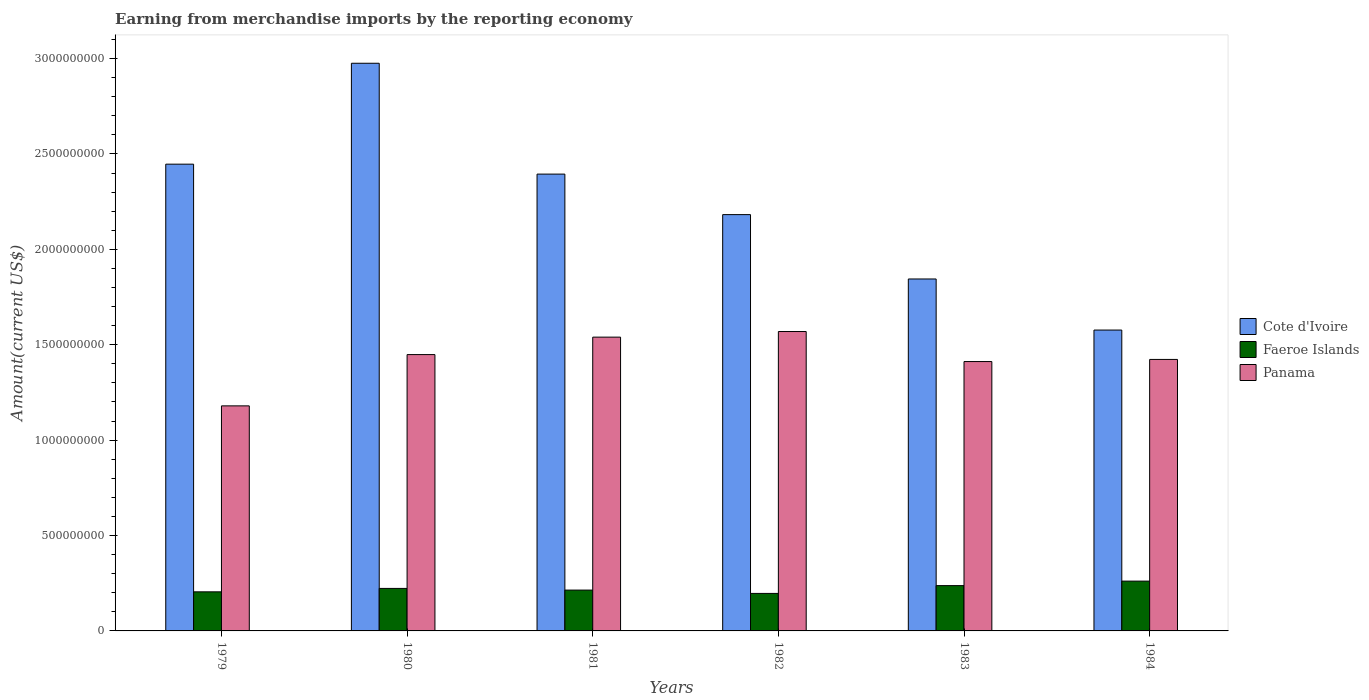Are the number of bars per tick equal to the number of legend labels?
Provide a succinct answer. Yes. Are the number of bars on each tick of the X-axis equal?
Ensure brevity in your answer.  Yes. How many bars are there on the 6th tick from the right?
Ensure brevity in your answer.  3. What is the label of the 2nd group of bars from the left?
Keep it short and to the point. 1980. What is the amount earned from merchandise imports in Panama in 1983?
Offer a terse response. 1.41e+09. Across all years, what is the maximum amount earned from merchandise imports in Cote d'Ivoire?
Make the answer very short. 2.98e+09. Across all years, what is the minimum amount earned from merchandise imports in Cote d'Ivoire?
Provide a short and direct response. 1.58e+09. In which year was the amount earned from merchandise imports in Faeroe Islands maximum?
Your answer should be very brief. 1984. In which year was the amount earned from merchandise imports in Faeroe Islands minimum?
Ensure brevity in your answer.  1982. What is the total amount earned from merchandise imports in Cote d'Ivoire in the graph?
Your response must be concise. 1.34e+1. What is the difference between the amount earned from merchandise imports in Cote d'Ivoire in 1982 and that in 1984?
Your answer should be very brief. 6.05e+08. What is the difference between the amount earned from merchandise imports in Panama in 1983 and the amount earned from merchandise imports in Cote d'Ivoire in 1984?
Provide a short and direct response. -1.65e+08. What is the average amount earned from merchandise imports in Faeroe Islands per year?
Your answer should be very brief. 2.23e+08. In the year 1982, what is the difference between the amount earned from merchandise imports in Cote d'Ivoire and amount earned from merchandise imports in Panama?
Provide a short and direct response. 6.13e+08. What is the ratio of the amount earned from merchandise imports in Cote d'Ivoire in 1979 to that in 1980?
Offer a very short reply. 0.82. What is the difference between the highest and the second highest amount earned from merchandise imports in Faeroe Islands?
Your response must be concise. 2.36e+07. What is the difference between the highest and the lowest amount earned from merchandise imports in Cote d'Ivoire?
Your answer should be very brief. 1.40e+09. In how many years, is the amount earned from merchandise imports in Cote d'Ivoire greater than the average amount earned from merchandise imports in Cote d'Ivoire taken over all years?
Your response must be concise. 3. What does the 2nd bar from the left in 1983 represents?
Offer a terse response. Faeroe Islands. What does the 3rd bar from the right in 1982 represents?
Provide a succinct answer. Cote d'Ivoire. How many bars are there?
Provide a short and direct response. 18. How many years are there in the graph?
Your answer should be compact. 6. What is the difference between two consecutive major ticks on the Y-axis?
Your response must be concise. 5.00e+08. Are the values on the major ticks of Y-axis written in scientific E-notation?
Your response must be concise. No. Does the graph contain any zero values?
Provide a succinct answer. No. Does the graph contain grids?
Your response must be concise. No. Where does the legend appear in the graph?
Make the answer very short. Center right. How are the legend labels stacked?
Keep it short and to the point. Vertical. What is the title of the graph?
Keep it short and to the point. Earning from merchandise imports by the reporting economy. What is the label or title of the Y-axis?
Keep it short and to the point. Amount(current US$). What is the Amount(current US$) in Cote d'Ivoire in 1979?
Ensure brevity in your answer.  2.45e+09. What is the Amount(current US$) of Faeroe Islands in 1979?
Make the answer very short. 2.05e+08. What is the Amount(current US$) of Panama in 1979?
Offer a terse response. 1.18e+09. What is the Amount(current US$) of Cote d'Ivoire in 1980?
Give a very brief answer. 2.98e+09. What is the Amount(current US$) of Faeroe Islands in 1980?
Your answer should be compact. 2.23e+08. What is the Amount(current US$) of Panama in 1980?
Your response must be concise. 1.45e+09. What is the Amount(current US$) in Cote d'Ivoire in 1981?
Your answer should be very brief. 2.39e+09. What is the Amount(current US$) in Faeroe Islands in 1981?
Provide a short and direct response. 2.14e+08. What is the Amount(current US$) of Panama in 1981?
Keep it short and to the point. 1.54e+09. What is the Amount(current US$) of Cote d'Ivoire in 1982?
Provide a short and direct response. 2.18e+09. What is the Amount(current US$) in Faeroe Islands in 1982?
Keep it short and to the point. 1.97e+08. What is the Amount(current US$) in Panama in 1982?
Make the answer very short. 1.57e+09. What is the Amount(current US$) of Cote d'Ivoire in 1983?
Offer a very short reply. 1.84e+09. What is the Amount(current US$) of Faeroe Islands in 1983?
Provide a succinct answer. 2.37e+08. What is the Amount(current US$) in Panama in 1983?
Provide a succinct answer. 1.41e+09. What is the Amount(current US$) of Cote d'Ivoire in 1984?
Ensure brevity in your answer.  1.58e+09. What is the Amount(current US$) of Faeroe Islands in 1984?
Give a very brief answer. 2.61e+08. What is the Amount(current US$) in Panama in 1984?
Make the answer very short. 1.42e+09. Across all years, what is the maximum Amount(current US$) of Cote d'Ivoire?
Give a very brief answer. 2.98e+09. Across all years, what is the maximum Amount(current US$) of Faeroe Islands?
Ensure brevity in your answer.  2.61e+08. Across all years, what is the maximum Amount(current US$) of Panama?
Ensure brevity in your answer.  1.57e+09. Across all years, what is the minimum Amount(current US$) in Cote d'Ivoire?
Your response must be concise. 1.58e+09. Across all years, what is the minimum Amount(current US$) of Faeroe Islands?
Provide a short and direct response. 1.97e+08. Across all years, what is the minimum Amount(current US$) of Panama?
Give a very brief answer. 1.18e+09. What is the total Amount(current US$) in Cote d'Ivoire in the graph?
Offer a terse response. 1.34e+1. What is the total Amount(current US$) of Faeroe Islands in the graph?
Ensure brevity in your answer.  1.34e+09. What is the total Amount(current US$) in Panama in the graph?
Offer a terse response. 8.57e+09. What is the difference between the Amount(current US$) of Cote d'Ivoire in 1979 and that in 1980?
Offer a very short reply. -5.29e+08. What is the difference between the Amount(current US$) in Faeroe Islands in 1979 and that in 1980?
Give a very brief answer. -1.79e+07. What is the difference between the Amount(current US$) in Panama in 1979 and that in 1980?
Give a very brief answer. -2.69e+08. What is the difference between the Amount(current US$) in Cote d'Ivoire in 1979 and that in 1981?
Provide a succinct answer. 5.20e+07. What is the difference between the Amount(current US$) of Faeroe Islands in 1979 and that in 1981?
Keep it short and to the point. -9.18e+06. What is the difference between the Amount(current US$) in Panama in 1979 and that in 1981?
Ensure brevity in your answer.  -3.60e+08. What is the difference between the Amount(current US$) in Cote d'Ivoire in 1979 and that in 1982?
Offer a terse response. 2.64e+08. What is the difference between the Amount(current US$) in Faeroe Islands in 1979 and that in 1982?
Provide a short and direct response. 8.24e+06. What is the difference between the Amount(current US$) of Panama in 1979 and that in 1982?
Ensure brevity in your answer.  -3.90e+08. What is the difference between the Amount(current US$) of Cote d'Ivoire in 1979 and that in 1983?
Provide a short and direct response. 6.02e+08. What is the difference between the Amount(current US$) in Faeroe Islands in 1979 and that in 1983?
Keep it short and to the point. -3.26e+07. What is the difference between the Amount(current US$) in Panama in 1979 and that in 1983?
Provide a short and direct response. -2.32e+08. What is the difference between the Amount(current US$) of Cote d'Ivoire in 1979 and that in 1984?
Make the answer very short. 8.69e+08. What is the difference between the Amount(current US$) of Faeroe Islands in 1979 and that in 1984?
Provide a succinct answer. -5.62e+07. What is the difference between the Amount(current US$) in Panama in 1979 and that in 1984?
Your answer should be very brief. -2.43e+08. What is the difference between the Amount(current US$) in Cote d'Ivoire in 1980 and that in 1981?
Offer a very short reply. 5.81e+08. What is the difference between the Amount(current US$) in Faeroe Islands in 1980 and that in 1981?
Your response must be concise. 8.76e+06. What is the difference between the Amount(current US$) of Panama in 1980 and that in 1981?
Provide a short and direct response. -9.15e+07. What is the difference between the Amount(current US$) in Cote d'Ivoire in 1980 and that in 1982?
Give a very brief answer. 7.93e+08. What is the difference between the Amount(current US$) of Faeroe Islands in 1980 and that in 1982?
Your answer should be very brief. 2.62e+07. What is the difference between the Amount(current US$) in Panama in 1980 and that in 1982?
Offer a terse response. -1.21e+08. What is the difference between the Amount(current US$) in Cote d'Ivoire in 1980 and that in 1983?
Your answer should be very brief. 1.13e+09. What is the difference between the Amount(current US$) of Faeroe Islands in 1980 and that in 1983?
Offer a very short reply. -1.47e+07. What is the difference between the Amount(current US$) in Panama in 1980 and that in 1983?
Keep it short and to the point. 3.65e+07. What is the difference between the Amount(current US$) of Cote d'Ivoire in 1980 and that in 1984?
Your answer should be very brief. 1.40e+09. What is the difference between the Amount(current US$) in Faeroe Islands in 1980 and that in 1984?
Provide a succinct answer. -3.83e+07. What is the difference between the Amount(current US$) of Panama in 1980 and that in 1984?
Provide a short and direct response. 2.54e+07. What is the difference between the Amount(current US$) of Cote d'Ivoire in 1981 and that in 1982?
Ensure brevity in your answer.  2.12e+08. What is the difference between the Amount(current US$) in Faeroe Islands in 1981 and that in 1982?
Your answer should be very brief. 1.74e+07. What is the difference between the Amount(current US$) of Panama in 1981 and that in 1982?
Offer a terse response. -2.93e+07. What is the difference between the Amount(current US$) in Cote d'Ivoire in 1981 and that in 1983?
Make the answer very short. 5.50e+08. What is the difference between the Amount(current US$) of Faeroe Islands in 1981 and that in 1983?
Offer a very short reply. -2.34e+07. What is the difference between the Amount(current US$) of Panama in 1981 and that in 1983?
Give a very brief answer. 1.28e+08. What is the difference between the Amount(current US$) in Cote d'Ivoire in 1981 and that in 1984?
Provide a short and direct response. 8.17e+08. What is the difference between the Amount(current US$) in Faeroe Islands in 1981 and that in 1984?
Give a very brief answer. -4.70e+07. What is the difference between the Amount(current US$) in Panama in 1981 and that in 1984?
Ensure brevity in your answer.  1.17e+08. What is the difference between the Amount(current US$) of Cote d'Ivoire in 1982 and that in 1983?
Offer a terse response. 3.37e+08. What is the difference between the Amount(current US$) in Faeroe Islands in 1982 and that in 1983?
Offer a terse response. -4.09e+07. What is the difference between the Amount(current US$) of Panama in 1982 and that in 1983?
Provide a succinct answer. 1.57e+08. What is the difference between the Amount(current US$) of Cote d'Ivoire in 1982 and that in 1984?
Offer a terse response. 6.05e+08. What is the difference between the Amount(current US$) in Faeroe Islands in 1982 and that in 1984?
Your answer should be very brief. -6.44e+07. What is the difference between the Amount(current US$) of Panama in 1982 and that in 1984?
Keep it short and to the point. 1.46e+08. What is the difference between the Amount(current US$) of Cote d'Ivoire in 1983 and that in 1984?
Provide a succinct answer. 2.68e+08. What is the difference between the Amount(current US$) in Faeroe Islands in 1983 and that in 1984?
Keep it short and to the point. -2.36e+07. What is the difference between the Amount(current US$) of Panama in 1983 and that in 1984?
Your answer should be compact. -1.11e+07. What is the difference between the Amount(current US$) of Cote d'Ivoire in 1979 and the Amount(current US$) of Faeroe Islands in 1980?
Offer a terse response. 2.22e+09. What is the difference between the Amount(current US$) of Cote d'Ivoire in 1979 and the Amount(current US$) of Panama in 1980?
Ensure brevity in your answer.  9.98e+08. What is the difference between the Amount(current US$) of Faeroe Islands in 1979 and the Amount(current US$) of Panama in 1980?
Offer a terse response. -1.24e+09. What is the difference between the Amount(current US$) of Cote d'Ivoire in 1979 and the Amount(current US$) of Faeroe Islands in 1981?
Your answer should be very brief. 2.23e+09. What is the difference between the Amount(current US$) of Cote d'Ivoire in 1979 and the Amount(current US$) of Panama in 1981?
Offer a terse response. 9.07e+08. What is the difference between the Amount(current US$) of Faeroe Islands in 1979 and the Amount(current US$) of Panama in 1981?
Offer a terse response. -1.34e+09. What is the difference between the Amount(current US$) of Cote d'Ivoire in 1979 and the Amount(current US$) of Faeroe Islands in 1982?
Keep it short and to the point. 2.25e+09. What is the difference between the Amount(current US$) in Cote d'Ivoire in 1979 and the Amount(current US$) in Panama in 1982?
Keep it short and to the point. 8.77e+08. What is the difference between the Amount(current US$) of Faeroe Islands in 1979 and the Amount(current US$) of Panama in 1982?
Provide a succinct answer. -1.36e+09. What is the difference between the Amount(current US$) of Cote d'Ivoire in 1979 and the Amount(current US$) of Faeroe Islands in 1983?
Provide a short and direct response. 2.21e+09. What is the difference between the Amount(current US$) of Cote d'Ivoire in 1979 and the Amount(current US$) of Panama in 1983?
Provide a succinct answer. 1.03e+09. What is the difference between the Amount(current US$) in Faeroe Islands in 1979 and the Amount(current US$) in Panama in 1983?
Provide a short and direct response. -1.21e+09. What is the difference between the Amount(current US$) in Cote d'Ivoire in 1979 and the Amount(current US$) in Faeroe Islands in 1984?
Give a very brief answer. 2.19e+09. What is the difference between the Amount(current US$) in Cote d'Ivoire in 1979 and the Amount(current US$) in Panama in 1984?
Provide a short and direct response. 1.02e+09. What is the difference between the Amount(current US$) of Faeroe Islands in 1979 and the Amount(current US$) of Panama in 1984?
Make the answer very short. -1.22e+09. What is the difference between the Amount(current US$) in Cote d'Ivoire in 1980 and the Amount(current US$) in Faeroe Islands in 1981?
Your response must be concise. 2.76e+09. What is the difference between the Amount(current US$) in Cote d'Ivoire in 1980 and the Amount(current US$) in Panama in 1981?
Your answer should be very brief. 1.44e+09. What is the difference between the Amount(current US$) in Faeroe Islands in 1980 and the Amount(current US$) in Panama in 1981?
Make the answer very short. -1.32e+09. What is the difference between the Amount(current US$) in Cote d'Ivoire in 1980 and the Amount(current US$) in Faeroe Islands in 1982?
Ensure brevity in your answer.  2.78e+09. What is the difference between the Amount(current US$) of Cote d'Ivoire in 1980 and the Amount(current US$) of Panama in 1982?
Provide a succinct answer. 1.41e+09. What is the difference between the Amount(current US$) of Faeroe Islands in 1980 and the Amount(current US$) of Panama in 1982?
Your response must be concise. -1.35e+09. What is the difference between the Amount(current US$) in Cote d'Ivoire in 1980 and the Amount(current US$) in Faeroe Islands in 1983?
Provide a short and direct response. 2.74e+09. What is the difference between the Amount(current US$) of Cote d'Ivoire in 1980 and the Amount(current US$) of Panama in 1983?
Your answer should be compact. 1.56e+09. What is the difference between the Amount(current US$) of Faeroe Islands in 1980 and the Amount(current US$) of Panama in 1983?
Your answer should be compact. -1.19e+09. What is the difference between the Amount(current US$) in Cote d'Ivoire in 1980 and the Amount(current US$) in Faeroe Islands in 1984?
Offer a very short reply. 2.71e+09. What is the difference between the Amount(current US$) in Cote d'Ivoire in 1980 and the Amount(current US$) in Panama in 1984?
Make the answer very short. 1.55e+09. What is the difference between the Amount(current US$) in Faeroe Islands in 1980 and the Amount(current US$) in Panama in 1984?
Your answer should be compact. -1.20e+09. What is the difference between the Amount(current US$) of Cote d'Ivoire in 1981 and the Amount(current US$) of Faeroe Islands in 1982?
Your answer should be very brief. 2.20e+09. What is the difference between the Amount(current US$) in Cote d'Ivoire in 1981 and the Amount(current US$) in Panama in 1982?
Give a very brief answer. 8.25e+08. What is the difference between the Amount(current US$) of Faeroe Islands in 1981 and the Amount(current US$) of Panama in 1982?
Offer a very short reply. -1.36e+09. What is the difference between the Amount(current US$) of Cote d'Ivoire in 1981 and the Amount(current US$) of Faeroe Islands in 1983?
Give a very brief answer. 2.16e+09. What is the difference between the Amount(current US$) in Cote d'Ivoire in 1981 and the Amount(current US$) in Panama in 1983?
Make the answer very short. 9.83e+08. What is the difference between the Amount(current US$) in Faeroe Islands in 1981 and the Amount(current US$) in Panama in 1983?
Offer a terse response. -1.20e+09. What is the difference between the Amount(current US$) of Cote d'Ivoire in 1981 and the Amount(current US$) of Faeroe Islands in 1984?
Keep it short and to the point. 2.13e+09. What is the difference between the Amount(current US$) of Cote d'Ivoire in 1981 and the Amount(current US$) of Panama in 1984?
Provide a succinct answer. 9.71e+08. What is the difference between the Amount(current US$) of Faeroe Islands in 1981 and the Amount(current US$) of Panama in 1984?
Give a very brief answer. -1.21e+09. What is the difference between the Amount(current US$) in Cote d'Ivoire in 1982 and the Amount(current US$) in Faeroe Islands in 1983?
Make the answer very short. 1.94e+09. What is the difference between the Amount(current US$) of Cote d'Ivoire in 1982 and the Amount(current US$) of Panama in 1983?
Ensure brevity in your answer.  7.70e+08. What is the difference between the Amount(current US$) of Faeroe Islands in 1982 and the Amount(current US$) of Panama in 1983?
Give a very brief answer. -1.22e+09. What is the difference between the Amount(current US$) in Cote d'Ivoire in 1982 and the Amount(current US$) in Faeroe Islands in 1984?
Your response must be concise. 1.92e+09. What is the difference between the Amount(current US$) of Cote d'Ivoire in 1982 and the Amount(current US$) of Panama in 1984?
Your response must be concise. 7.59e+08. What is the difference between the Amount(current US$) in Faeroe Islands in 1982 and the Amount(current US$) in Panama in 1984?
Ensure brevity in your answer.  -1.23e+09. What is the difference between the Amount(current US$) of Cote d'Ivoire in 1983 and the Amount(current US$) of Faeroe Islands in 1984?
Provide a succinct answer. 1.58e+09. What is the difference between the Amount(current US$) in Cote d'Ivoire in 1983 and the Amount(current US$) in Panama in 1984?
Give a very brief answer. 4.22e+08. What is the difference between the Amount(current US$) in Faeroe Islands in 1983 and the Amount(current US$) in Panama in 1984?
Offer a very short reply. -1.19e+09. What is the average Amount(current US$) in Cote d'Ivoire per year?
Provide a succinct answer. 2.24e+09. What is the average Amount(current US$) of Faeroe Islands per year?
Offer a terse response. 2.23e+08. What is the average Amount(current US$) of Panama per year?
Offer a very short reply. 1.43e+09. In the year 1979, what is the difference between the Amount(current US$) of Cote d'Ivoire and Amount(current US$) of Faeroe Islands?
Your answer should be very brief. 2.24e+09. In the year 1979, what is the difference between the Amount(current US$) of Cote d'Ivoire and Amount(current US$) of Panama?
Offer a terse response. 1.27e+09. In the year 1979, what is the difference between the Amount(current US$) of Faeroe Islands and Amount(current US$) of Panama?
Provide a short and direct response. -9.75e+08. In the year 1980, what is the difference between the Amount(current US$) of Cote d'Ivoire and Amount(current US$) of Faeroe Islands?
Offer a terse response. 2.75e+09. In the year 1980, what is the difference between the Amount(current US$) of Cote d'Ivoire and Amount(current US$) of Panama?
Give a very brief answer. 1.53e+09. In the year 1980, what is the difference between the Amount(current US$) in Faeroe Islands and Amount(current US$) in Panama?
Offer a very short reply. -1.23e+09. In the year 1981, what is the difference between the Amount(current US$) of Cote d'Ivoire and Amount(current US$) of Faeroe Islands?
Offer a very short reply. 2.18e+09. In the year 1981, what is the difference between the Amount(current US$) in Cote d'Ivoire and Amount(current US$) in Panama?
Your response must be concise. 8.55e+08. In the year 1981, what is the difference between the Amount(current US$) of Faeroe Islands and Amount(current US$) of Panama?
Make the answer very short. -1.33e+09. In the year 1982, what is the difference between the Amount(current US$) in Cote d'Ivoire and Amount(current US$) in Faeroe Islands?
Your answer should be very brief. 1.99e+09. In the year 1982, what is the difference between the Amount(current US$) in Cote d'Ivoire and Amount(current US$) in Panama?
Provide a short and direct response. 6.13e+08. In the year 1982, what is the difference between the Amount(current US$) of Faeroe Islands and Amount(current US$) of Panama?
Provide a short and direct response. -1.37e+09. In the year 1983, what is the difference between the Amount(current US$) of Cote d'Ivoire and Amount(current US$) of Faeroe Islands?
Keep it short and to the point. 1.61e+09. In the year 1983, what is the difference between the Amount(current US$) of Cote d'Ivoire and Amount(current US$) of Panama?
Offer a terse response. 4.33e+08. In the year 1983, what is the difference between the Amount(current US$) of Faeroe Islands and Amount(current US$) of Panama?
Your answer should be very brief. -1.17e+09. In the year 1984, what is the difference between the Amount(current US$) of Cote d'Ivoire and Amount(current US$) of Faeroe Islands?
Your answer should be compact. 1.32e+09. In the year 1984, what is the difference between the Amount(current US$) in Cote d'Ivoire and Amount(current US$) in Panama?
Offer a terse response. 1.54e+08. In the year 1984, what is the difference between the Amount(current US$) in Faeroe Islands and Amount(current US$) in Panama?
Provide a short and direct response. -1.16e+09. What is the ratio of the Amount(current US$) in Cote d'Ivoire in 1979 to that in 1980?
Offer a terse response. 0.82. What is the ratio of the Amount(current US$) of Faeroe Islands in 1979 to that in 1980?
Your answer should be compact. 0.92. What is the ratio of the Amount(current US$) in Panama in 1979 to that in 1980?
Provide a short and direct response. 0.81. What is the ratio of the Amount(current US$) of Cote d'Ivoire in 1979 to that in 1981?
Give a very brief answer. 1.02. What is the ratio of the Amount(current US$) in Faeroe Islands in 1979 to that in 1981?
Provide a short and direct response. 0.96. What is the ratio of the Amount(current US$) of Panama in 1979 to that in 1981?
Your response must be concise. 0.77. What is the ratio of the Amount(current US$) in Cote d'Ivoire in 1979 to that in 1982?
Give a very brief answer. 1.12. What is the ratio of the Amount(current US$) in Faeroe Islands in 1979 to that in 1982?
Give a very brief answer. 1.04. What is the ratio of the Amount(current US$) of Panama in 1979 to that in 1982?
Offer a very short reply. 0.75. What is the ratio of the Amount(current US$) in Cote d'Ivoire in 1979 to that in 1983?
Offer a terse response. 1.33. What is the ratio of the Amount(current US$) in Faeroe Islands in 1979 to that in 1983?
Give a very brief answer. 0.86. What is the ratio of the Amount(current US$) in Panama in 1979 to that in 1983?
Make the answer very short. 0.84. What is the ratio of the Amount(current US$) in Cote d'Ivoire in 1979 to that in 1984?
Provide a succinct answer. 1.55. What is the ratio of the Amount(current US$) of Faeroe Islands in 1979 to that in 1984?
Offer a very short reply. 0.78. What is the ratio of the Amount(current US$) of Panama in 1979 to that in 1984?
Your response must be concise. 0.83. What is the ratio of the Amount(current US$) of Cote d'Ivoire in 1980 to that in 1981?
Provide a succinct answer. 1.24. What is the ratio of the Amount(current US$) in Faeroe Islands in 1980 to that in 1981?
Offer a very short reply. 1.04. What is the ratio of the Amount(current US$) in Panama in 1980 to that in 1981?
Ensure brevity in your answer.  0.94. What is the ratio of the Amount(current US$) of Cote d'Ivoire in 1980 to that in 1982?
Offer a terse response. 1.36. What is the ratio of the Amount(current US$) in Faeroe Islands in 1980 to that in 1982?
Provide a short and direct response. 1.13. What is the ratio of the Amount(current US$) in Panama in 1980 to that in 1982?
Provide a short and direct response. 0.92. What is the ratio of the Amount(current US$) of Cote d'Ivoire in 1980 to that in 1983?
Your response must be concise. 1.61. What is the ratio of the Amount(current US$) of Faeroe Islands in 1980 to that in 1983?
Give a very brief answer. 0.94. What is the ratio of the Amount(current US$) of Panama in 1980 to that in 1983?
Make the answer very short. 1.03. What is the ratio of the Amount(current US$) in Cote d'Ivoire in 1980 to that in 1984?
Make the answer very short. 1.89. What is the ratio of the Amount(current US$) in Faeroe Islands in 1980 to that in 1984?
Your answer should be very brief. 0.85. What is the ratio of the Amount(current US$) of Panama in 1980 to that in 1984?
Your answer should be compact. 1.02. What is the ratio of the Amount(current US$) of Cote d'Ivoire in 1981 to that in 1982?
Provide a succinct answer. 1.1. What is the ratio of the Amount(current US$) of Faeroe Islands in 1981 to that in 1982?
Provide a succinct answer. 1.09. What is the ratio of the Amount(current US$) of Panama in 1981 to that in 1982?
Your answer should be compact. 0.98. What is the ratio of the Amount(current US$) of Cote d'Ivoire in 1981 to that in 1983?
Provide a succinct answer. 1.3. What is the ratio of the Amount(current US$) in Faeroe Islands in 1981 to that in 1983?
Your answer should be very brief. 0.9. What is the ratio of the Amount(current US$) in Panama in 1981 to that in 1983?
Your answer should be compact. 1.09. What is the ratio of the Amount(current US$) of Cote d'Ivoire in 1981 to that in 1984?
Offer a terse response. 1.52. What is the ratio of the Amount(current US$) of Faeroe Islands in 1981 to that in 1984?
Provide a short and direct response. 0.82. What is the ratio of the Amount(current US$) of Panama in 1981 to that in 1984?
Give a very brief answer. 1.08. What is the ratio of the Amount(current US$) in Cote d'Ivoire in 1982 to that in 1983?
Your response must be concise. 1.18. What is the ratio of the Amount(current US$) in Faeroe Islands in 1982 to that in 1983?
Ensure brevity in your answer.  0.83. What is the ratio of the Amount(current US$) in Panama in 1982 to that in 1983?
Provide a short and direct response. 1.11. What is the ratio of the Amount(current US$) in Cote d'Ivoire in 1982 to that in 1984?
Make the answer very short. 1.38. What is the ratio of the Amount(current US$) of Faeroe Islands in 1982 to that in 1984?
Your response must be concise. 0.75. What is the ratio of the Amount(current US$) of Panama in 1982 to that in 1984?
Your response must be concise. 1.1. What is the ratio of the Amount(current US$) in Cote d'Ivoire in 1983 to that in 1984?
Your answer should be compact. 1.17. What is the ratio of the Amount(current US$) in Faeroe Islands in 1983 to that in 1984?
Offer a terse response. 0.91. What is the difference between the highest and the second highest Amount(current US$) in Cote d'Ivoire?
Make the answer very short. 5.29e+08. What is the difference between the highest and the second highest Amount(current US$) in Faeroe Islands?
Offer a very short reply. 2.36e+07. What is the difference between the highest and the second highest Amount(current US$) in Panama?
Make the answer very short. 2.93e+07. What is the difference between the highest and the lowest Amount(current US$) in Cote d'Ivoire?
Make the answer very short. 1.40e+09. What is the difference between the highest and the lowest Amount(current US$) in Faeroe Islands?
Provide a succinct answer. 6.44e+07. What is the difference between the highest and the lowest Amount(current US$) in Panama?
Provide a succinct answer. 3.90e+08. 